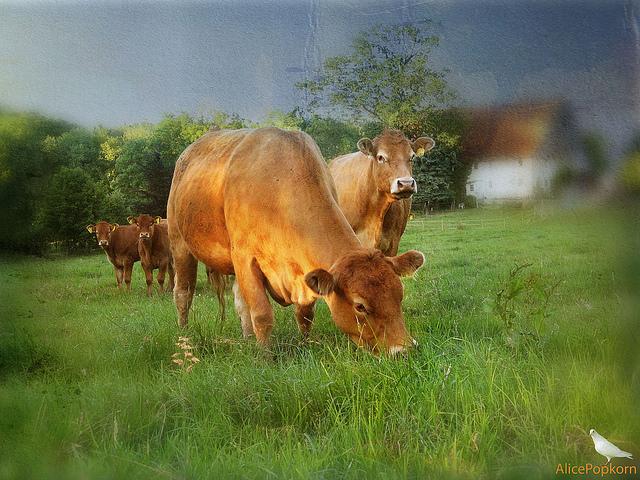How many cows are there?
Write a very short answer. 4. Are all the cows eating grass?
Short answer required. No. What liquid comes from these animals?
Be succinct. Milk. 